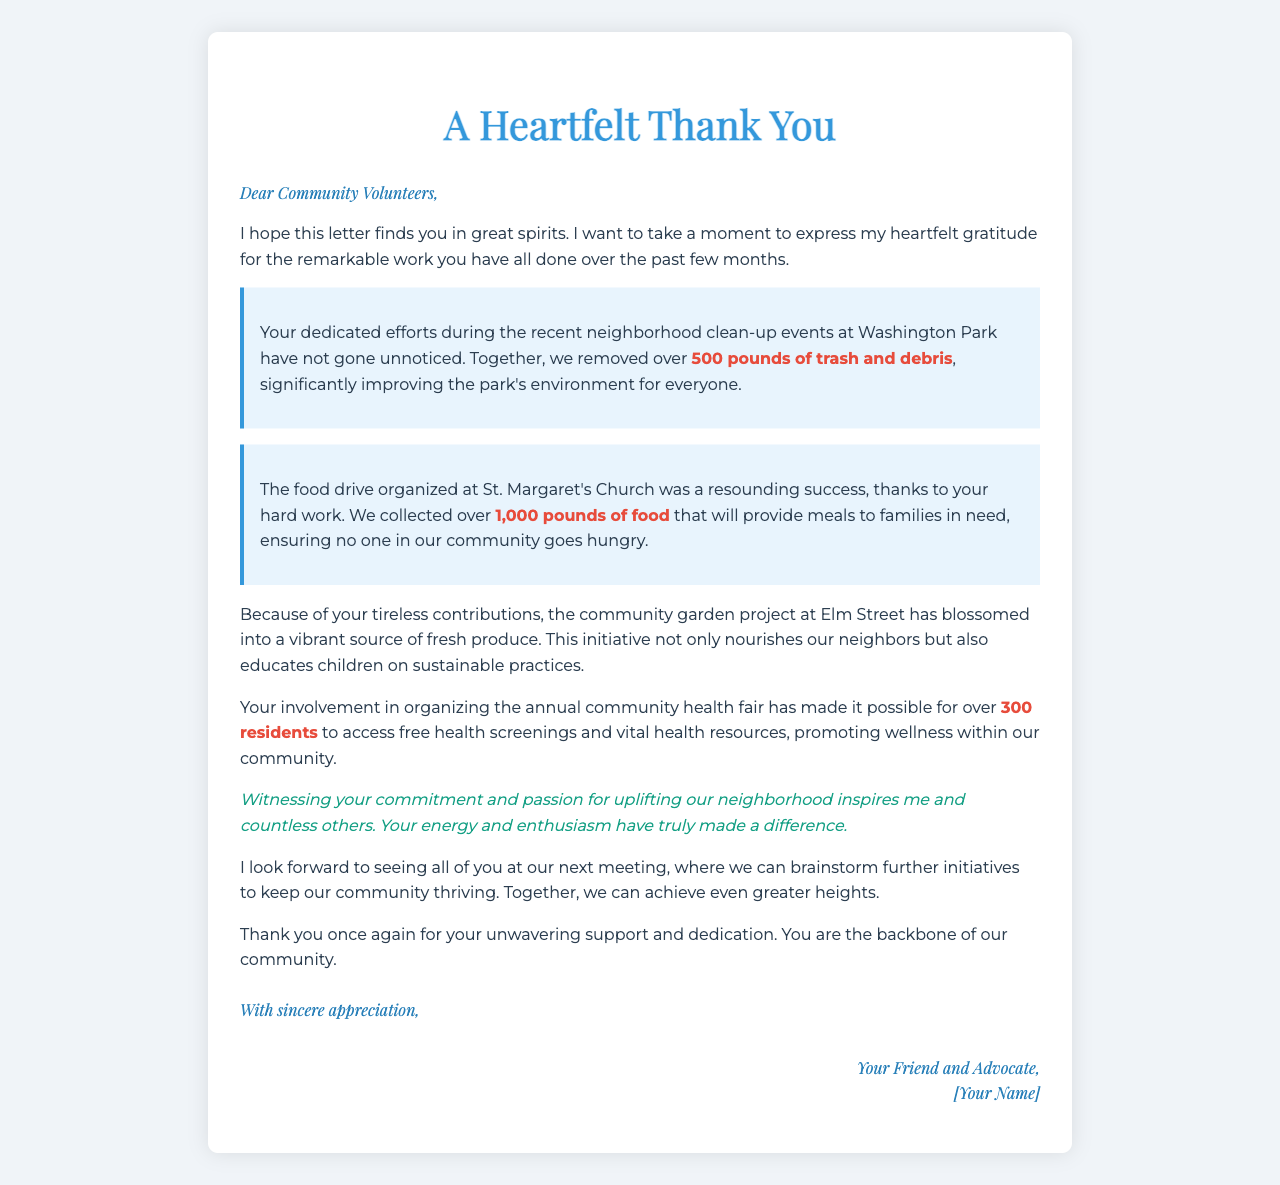What is the title of the letter? The title of the letter is prominently displayed at the top and is a reflection of the letter's intent to express gratitude.
Answer: A Heartfelt Thank You How many pounds of trash were removed from Washington Park? The letter specifies the amount of trash collected during the neighborhood clean-up event.
Answer: 500 pounds What was the total amount of food collected during the food drive? The letter details the contribution of food collected for families in need through the food drive.
Answer: 1,000 pounds How many residents accessed free health screenings at the health fair? The letter mentions the number of residents who benefited from health screenings due to the volunteers' efforts.
Answer: 300 residents What initiative does the community garden project at Elm Street support? The letter describes the purpose of the community garden project in terms of its impact on local residents and education.
Answer: Nourishes our neighbors What kind of events did the volunteers participate in according to the letter? The letter outlines the types of community service events the volunteers were involved in, highlighting their engagement.
Answer: Neighborhood clean-up events What does the author express gratitude for? The letter emphasizes specific contributions the volunteers made, focusing on the impact they had on the community.
Answer: Their unwavering support and dedication What feeling does the author hope the volunteers have as they read the letter? The opening paragraph sets a positive tone and expresses a sentiment towards the volunteers' emotional state while reading.
Answer: Great spirits What is the author's relationship to the community volunteers? The signature at the end of the letter indicates a personal connection the author has with the volunteers.
Answer: Friend and Advocate 